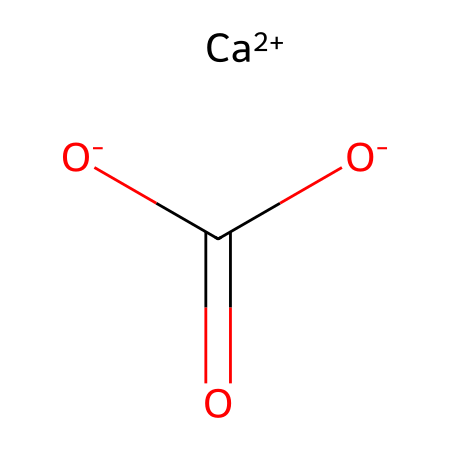What is the main component of marble? The SMILES representation indicates the presence of calcium ions (Ca+2) and carbonate ions. The carbonate ion is represented by the formula C(=O)(O)O, which is indicative of calcium carbonate, the primary component of marble.
Answer: calcium carbonate How many carbon atoms are in the structure? In the provided SMILES, there is one central carbon atom in the carbonate ion, as seen in C(=O)(O)O. Thus, the total number of carbon atoms is one.
Answer: one What is the oxidation state of the calcium ion? In the SMILES notation, the calcium ion is represented as [Ca+2], indicating it has a +2 oxidation state, which is characteristic of calcium in its ionic form.
Answer: +2 How many oxygen atoms are present in this chemical composition? The SMILES shows a carbonate ion that contains three oxygen atoms (O) as part of its structure. Thus, the total number of oxygen atoms in the compound is three.
Answer: three What type of solid is represented by this chemical composition? The presence of calcium carbonate (CaCO3) indicates that it is a mineral solid type, specifically a sedimentary rock and a common form in natural limestone and marble.
Answer: mineral solid What role does the carbonate ion play in marble's properties? The carbonate ion contributes to the hardness and durability of marble, which is significant in sculpture and architecture. The carbonate's structure facilitates the bonding with calcium, enhancing the physical properties of the solid.
Answer: hardness and durability How does the structure of marble contribute to its use in sculptures? Marble's crystalline structure, primarily composed of calcium carbonate, provides a fine polish and aesthetic beauty, making it a favored material in classical sculptures. Its malleability allows for intricate carving, which is essential in artistry.
Answer: fine polish and malleability 